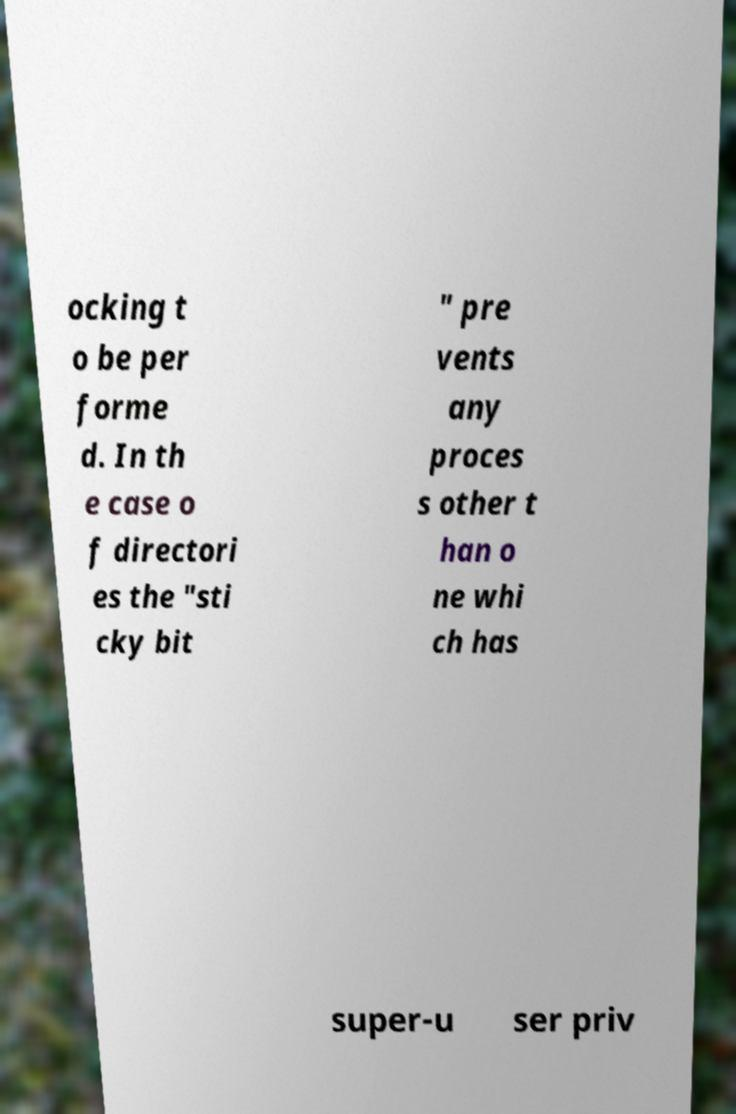For documentation purposes, I need the text within this image transcribed. Could you provide that? ocking t o be per forme d. In th e case o f directori es the "sti cky bit " pre vents any proces s other t han o ne whi ch has super-u ser priv 